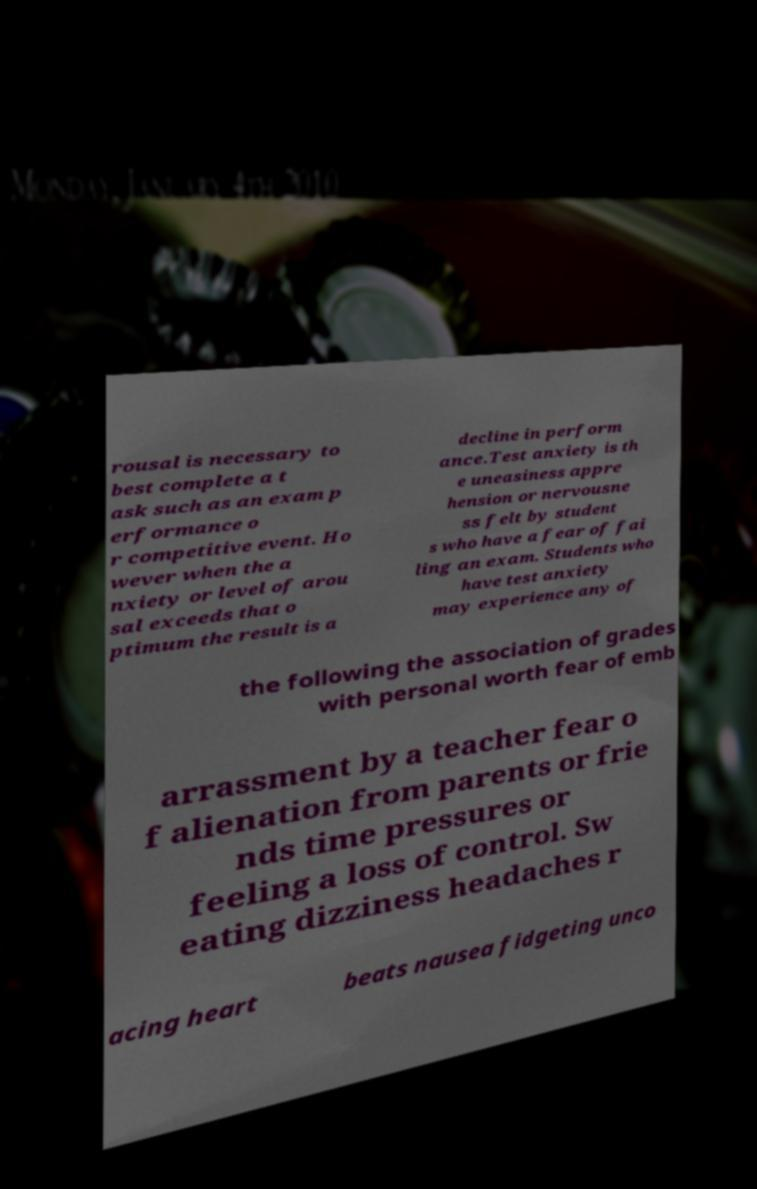Please identify and transcribe the text found in this image. rousal is necessary to best complete a t ask such as an exam p erformance o r competitive event. Ho wever when the a nxiety or level of arou sal exceeds that o ptimum the result is a decline in perform ance.Test anxiety is th e uneasiness appre hension or nervousne ss felt by student s who have a fear of fai ling an exam. Students who have test anxiety may experience any of the following the association of grades with personal worth fear of emb arrassment by a teacher fear o f alienation from parents or frie nds time pressures or feeling a loss of control. Sw eating dizziness headaches r acing heart beats nausea fidgeting unco 